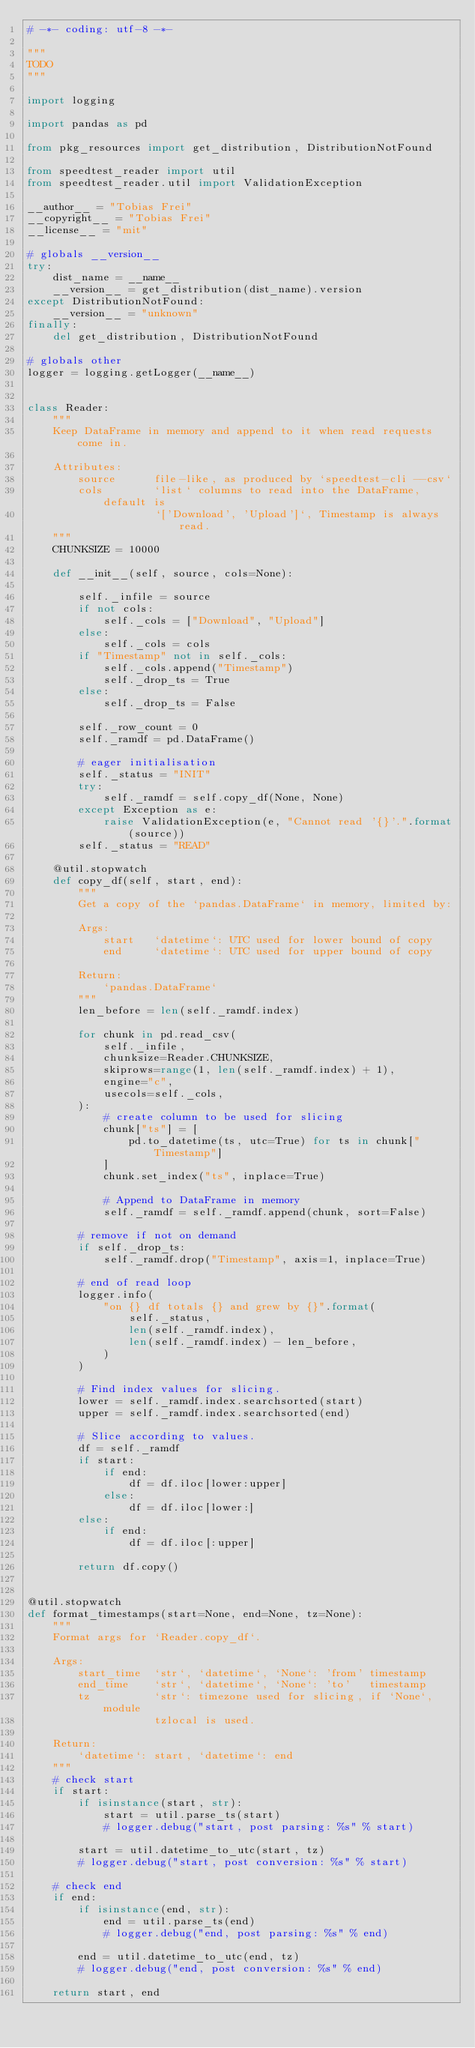<code> <loc_0><loc_0><loc_500><loc_500><_Python_># -*- coding: utf-8 -*-

"""
TODO
"""

import logging

import pandas as pd

from pkg_resources import get_distribution, DistributionNotFound

from speedtest_reader import util
from speedtest_reader.util import ValidationException

__author__ = "Tobias Frei"
__copyright__ = "Tobias Frei"
__license__ = "mit"

# globals __version__
try:
    dist_name = __name__
    __version__ = get_distribution(dist_name).version
except DistributionNotFound:
    __version__ = "unknown"
finally:
    del get_distribution, DistributionNotFound

# globals other
logger = logging.getLogger(__name__)


class Reader:
    """
    Keep DataFrame in memory and append to it when read requests come in.

    Attributes:
        source      file-like, as produced by `speedtest-cli --csv`
        cols        `list` columns to read into the DataFrame, default is
                    `['Download', 'Upload']`, Timestamp is always read.
    """
    CHUNKSIZE = 10000

    def __init__(self, source, cols=None):

        self._infile = source
        if not cols:
            self._cols = ["Download", "Upload"]
        else:
            self._cols = cols
        if "Timestamp" not in self._cols:
            self._cols.append("Timestamp")
            self._drop_ts = True
        else:
            self._drop_ts = False

        self._row_count = 0
        self._ramdf = pd.DataFrame()

        # eager initialisation
        self._status = "INIT"
        try:
            self._ramdf = self.copy_df(None, None)
        except Exception as e:
            raise ValidationException(e, "Cannot read '{}'.".format(source))
        self._status = "READ"

    @util.stopwatch
    def copy_df(self, start, end):
        """
        Get a copy of the `pandas.DataFrame` in memory, limited by:

        Args:
            start   `datetime`: UTC used for lower bound of copy
            end     `datetime`: UTC used for upper bound of copy

        Return:
            `pandas.DataFrame`
        """
        len_before = len(self._ramdf.index)

        for chunk in pd.read_csv(
            self._infile,
            chunksize=Reader.CHUNKSIZE,
            skiprows=range(1, len(self._ramdf.index) + 1),
            engine="c",
            usecols=self._cols,
        ):
            # create column to be used for slicing
            chunk["ts"] = [
                pd.to_datetime(ts, utc=True) for ts in chunk["Timestamp"]
            ]
            chunk.set_index("ts", inplace=True)

            # Append to DataFrame in memory
            self._ramdf = self._ramdf.append(chunk, sort=False)

        # remove if not on demand
        if self._drop_ts:
            self._ramdf.drop("Timestamp", axis=1, inplace=True)

        # end of read loop
        logger.info(
            "on {} df totals {} and grew by {}".format(
                self._status,
                len(self._ramdf.index),
                len(self._ramdf.index) - len_before,
            )
        )

        # Find index values for slicing.
        lower = self._ramdf.index.searchsorted(start)
        upper = self._ramdf.index.searchsorted(end)

        # Slice according to values.
        df = self._ramdf
        if start:
            if end:
                df = df.iloc[lower:upper]
            else:
                df = df.iloc[lower:]
        else:
            if end:
                df = df.iloc[:upper]

        return df.copy()


@util.stopwatch
def format_timestamps(start=None, end=None, tz=None):
    """
    Format args for `Reader.copy_df`.

    Args:
        start_time  `str`, `datetime`, `None`: 'from' timestamp
        end_time    `str`, `datetime`, `None`: 'to'   timestamp
        tz          `str`: timezone used for slicing, if `None`, module
                    tzlocal is used.

    Return:
        `datetime`: start, `datetime`: end
    """
    # check start
    if start:
        if isinstance(start, str):
            start = util.parse_ts(start)
            # logger.debug("start, post parsing: %s" % start)

        start = util.datetime_to_utc(start, tz)
        # logger.debug("start, post conversion: %s" % start)

    # check end
    if end:
        if isinstance(end, str):
            end = util.parse_ts(end)
            # logger.debug("end, post parsing: %s" % end)

        end = util.datetime_to_utc(end, tz)
        # logger.debug("end, post conversion: %s" % end)

    return start, end
</code> 